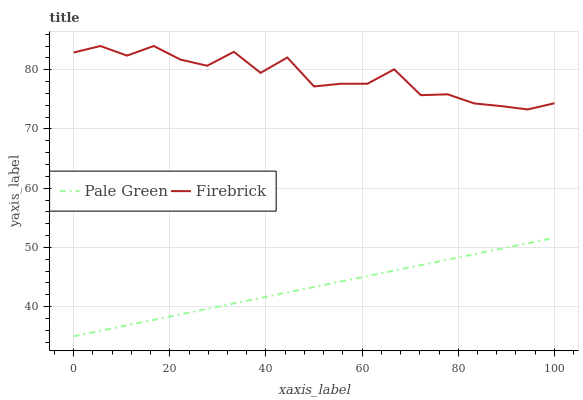Does Pale Green have the maximum area under the curve?
Answer yes or no. No. Is Pale Green the roughest?
Answer yes or no. No. Does Pale Green have the highest value?
Answer yes or no. No. Is Pale Green less than Firebrick?
Answer yes or no. Yes. Is Firebrick greater than Pale Green?
Answer yes or no. Yes. Does Pale Green intersect Firebrick?
Answer yes or no. No. 